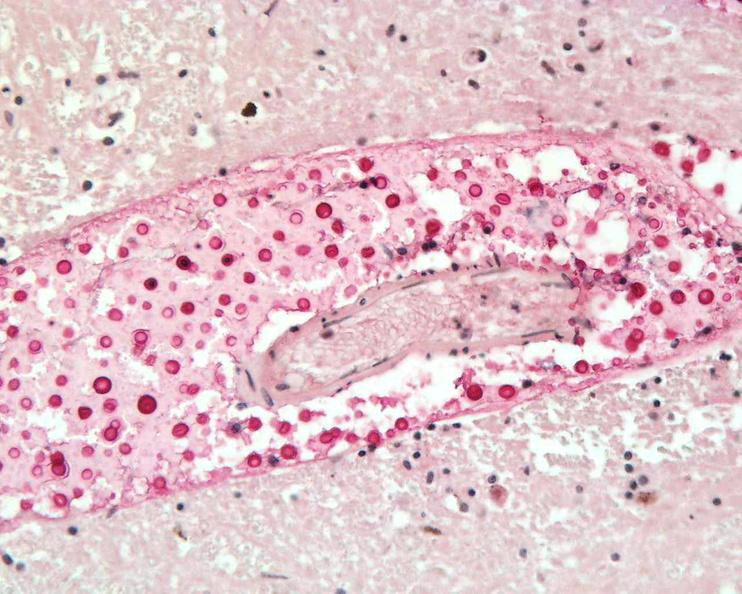what does this image show?
Answer the question using a single word or phrase. Brain 